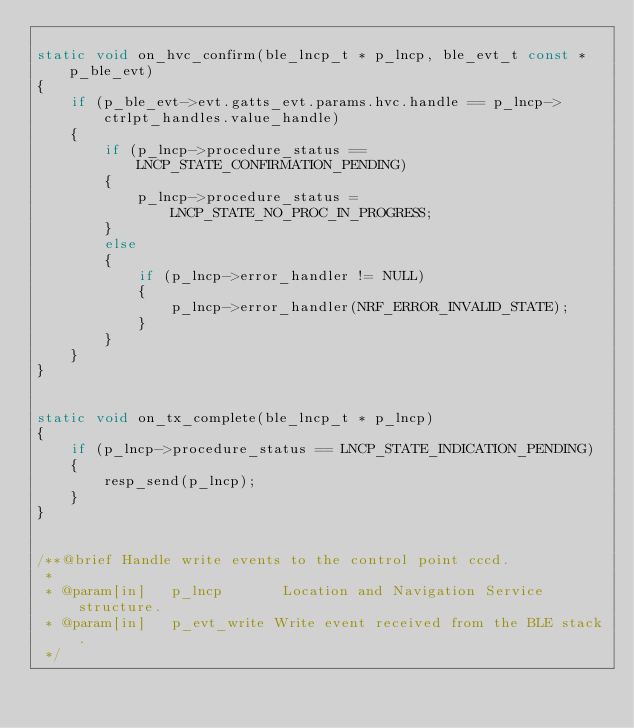Convert code to text. <code><loc_0><loc_0><loc_500><loc_500><_C_>
static void on_hvc_confirm(ble_lncp_t * p_lncp, ble_evt_t const * p_ble_evt)
{
    if (p_ble_evt->evt.gatts_evt.params.hvc.handle == p_lncp->ctrlpt_handles.value_handle)
    {
        if (p_lncp->procedure_status == LNCP_STATE_CONFIRMATION_PENDING)
        {
            p_lncp->procedure_status = LNCP_STATE_NO_PROC_IN_PROGRESS;
        }
        else
        {
            if (p_lncp->error_handler != NULL)
            {
                p_lncp->error_handler(NRF_ERROR_INVALID_STATE);
            }
        }
    }
}


static void on_tx_complete(ble_lncp_t * p_lncp)
{
    if (p_lncp->procedure_status == LNCP_STATE_INDICATION_PENDING)
    {
        resp_send(p_lncp);
    }
}


/**@brief Handle write events to the control point cccd.
 *
 * @param[in]   p_lncp       Location and Navigation Service structure.
 * @param[in]   p_evt_write Write event received from the BLE stack.
 */</code> 